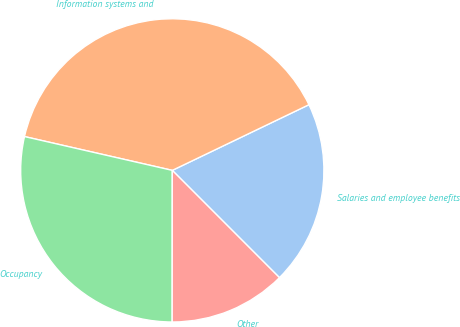Convert chart. <chart><loc_0><loc_0><loc_500><loc_500><pie_chart><fcel>Salaries and employee benefits<fcel>Information systems and<fcel>Occupancy<fcel>Other<nl><fcel>19.64%<fcel>39.29%<fcel>28.57%<fcel>12.5%<nl></chart> 